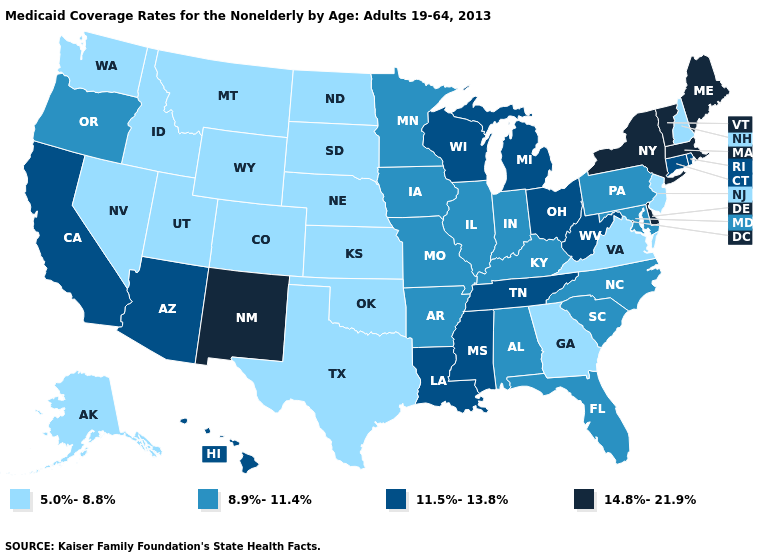What is the value of South Dakota?
Give a very brief answer. 5.0%-8.8%. Name the states that have a value in the range 11.5%-13.8%?
Be succinct. Arizona, California, Connecticut, Hawaii, Louisiana, Michigan, Mississippi, Ohio, Rhode Island, Tennessee, West Virginia, Wisconsin. Name the states that have a value in the range 8.9%-11.4%?
Be succinct. Alabama, Arkansas, Florida, Illinois, Indiana, Iowa, Kentucky, Maryland, Minnesota, Missouri, North Carolina, Oregon, Pennsylvania, South Carolina. Among the states that border Arizona , does Utah have the highest value?
Short answer required. No. Name the states that have a value in the range 5.0%-8.8%?
Short answer required. Alaska, Colorado, Georgia, Idaho, Kansas, Montana, Nebraska, Nevada, New Hampshire, New Jersey, North Dakota, Oklahoma, South Dakota, Texas, Utah, Virginia, Washington, Wyoming. Name the states that have a value in the range 8.9%-11.4%?
Write a very short answer. Alabama, Arkansas, Florida, Illinois, Indiana, Iowa, Kentucky, Maryland, Minnesota, Missouri, North Carolina, Oregon, Pennsylvania, South Carolina. What is the value of Missouri?
Give a very brief answer. 8.9%-11.4%. Name the states that have a value in the range 8.9%-11.4%?
Write a very short answer. Alabama, Arkansas, Florida, Illinois, Indiana, Iowa, Kentucky, Maryland, Minnesota, Missouri, North Carolina, Oregon, Pennsylvania, South Carolina. Among the states that border Nevada , does Arizona have the lowest value?
Keep it brief. No. Name the states that have a value in the range 11.5%-13.8%?
Give a very brief answer. Arizona, California, Connecticut, Hawaii, Louisiana, Michigan, Mississippi, Ohio, Rhode Island, Tennessee, West Virginia, Wisconsin. Does Mississippi have the same value as Wyoming?
Short answer required. No. Among the states that border Arizona , does New Mexico have the highest value?
Answer briefly. Yes. Which states have the highest value in the USA?
Keep it brief. Delaware, Maine, Massachusetts, New Mexico, New York, Vermont. What is the value of Louisiana?
Answer briefly. 11.5%-13.8%. Name the states that have a value in the range 8.9%-11.4%?
Give a very brief answer. Alabama, Arkansas, Florida, Illinois, Indiana, Iowa, Kentucky, Maryland, Minnesota, Missouri, North Carolina, Oregon, Pennsylvania, South Carolina. 